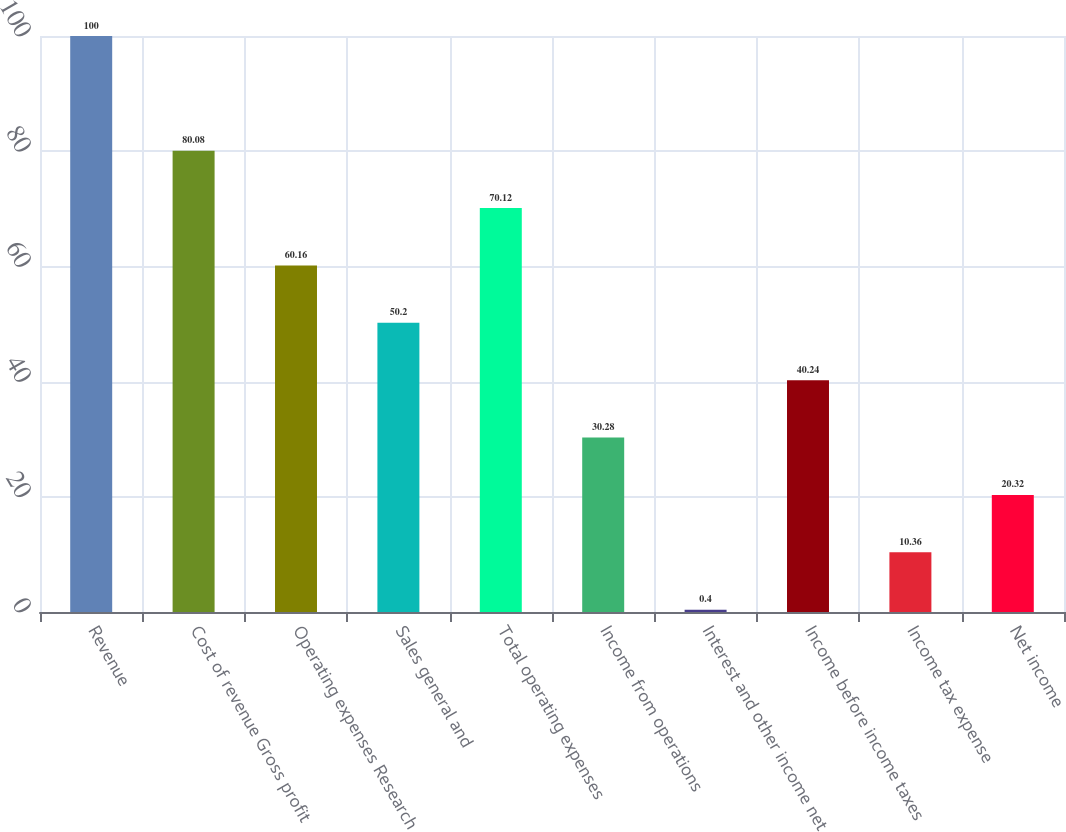Convert chart. <chart><loc_0><loc_0><loc_500><loc_500><bar_chart><fcel>Revenue<fcel>Cost of revenue Gross profit<fcel>Operating expenses Research<fcel>Sales general and<fcel>Total operating expenses<fcel>Income from operations<fcel>Interest and other income net<fcel>Income before income taxes<fcel>Income tax expense<fcel>Net income<nl><fcel>100<fcel>80.08<fcel>60.16<fcel>50.2<fcel>70.12<fcel>30.28<fcel>0.4<fcel>40.24<fcel>10.36<fcel>20.32<nl></chart> 